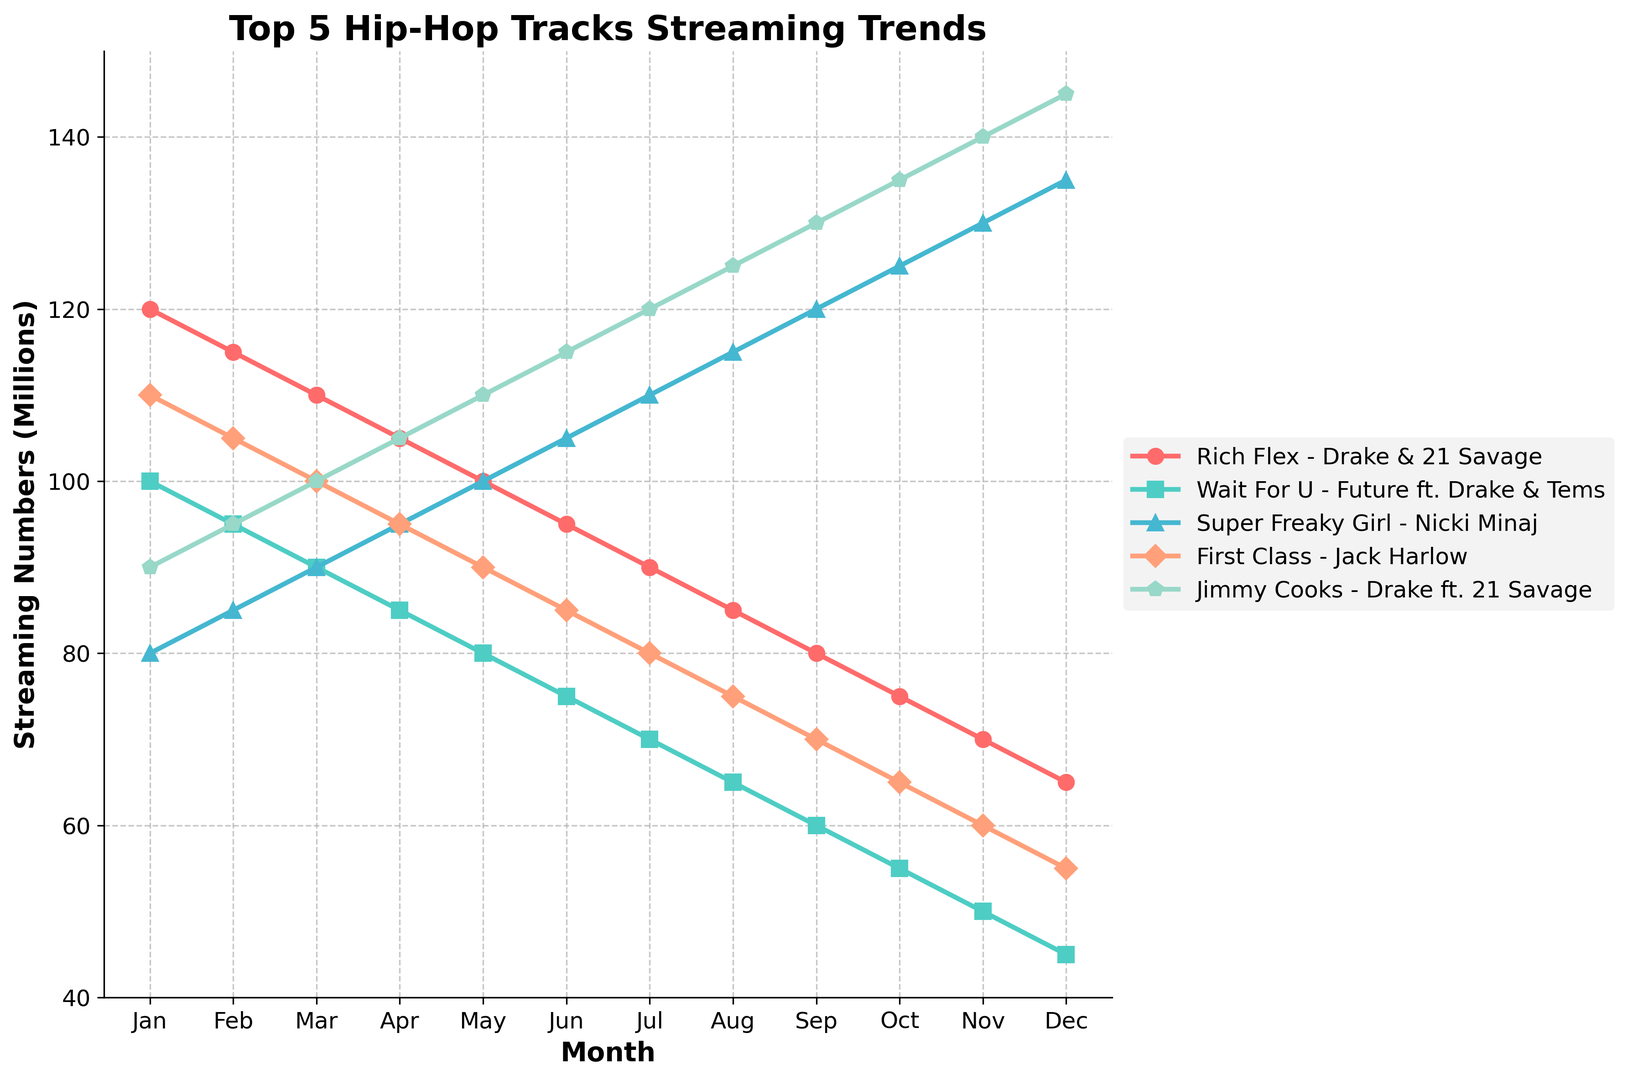Which track had the highest streaming numbers in December? Looking at the December points on the chart, "Jimmy Cooks - Drake ft. 21 Savage" has the highest value at 145 million streams.
Answer: "Jimmy Cooks - Drake ft. 21 Savage" Which track had a steady decline in streaming numbers throughout the year? By observing the trends, both "Rich Flex - Drake & 21 Savage" and "First Class - Jack Harlow" show a steady decline in streaming numbers each month.
Answer: "Rich Flex - Drake & 21 Savage" and "First Class - Jack Harlow" Which track showed the most significant increase in streaming numbers over the past 12 months? "Super Freaky Girl - Nicki Minaj" started at 80 million in January and increased to 135 million in December, the most significant increase among all tracks.
Answer: "Super Freaky Girl - Nicki Minaj" What is the difference in streaming numbers between "Rich Flex - Drake & 21 Savage" and "Wait For U - Future ft. Drake & Tems" in November? In November, "Rich Flex - Drake & 21 Savage" had 70 million streams and "Wait For U - Future ft. Drake & Tems" had 50 million streams. The difference is 70 - 50 = 20 million.
Answer: 20 million Which two tracks cross paths (intersect) in their streaming numbers graph, and in which months? "Rich Flex - Drake & 21 Savage" and "First Class - Jack Harlow" cross paths twice, in August and November.
Answer: "Rich Flex - Drake & 21 Savage" and "First Class - Jack Harlow" in August and November What is the average streaming number of "Super Freaky Girl - Nicki Minaj" for the first half of the year (Jan to Jun)? Adding the first six months for "Super Freaky Girl - Nicki Minaj" (80 + 85 + 90 + 95 + 100 + 105) gives 555. Dividing by 6 months gives an average of 555/6 = 92.5 million.
Answer: 92.5 million Compare the trend of "Jimmy Cooks - Drake ft. 21 Savage" and "Rich Flex - Drake & 21 Savage" over the months. Which had a consistent rising trend? "Jimmy Cooks - Drake ft. 21 Savage" shows a consistent rising trend from January to December, while "Rich Flex - Drake & 21 Savage" shows a consistent decline.
Answer: "Jimmy Cooks - Drake ft. 21 Savage" In which month did "Wait For U - Future ft. Drake & Tems" equal the streaming number of "First Class - Jack Harlow"? Both tracks had equal streaming numbers at 75 million in June.
Answer: June 